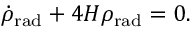<formula> <loc_0><loc_0><loc_500><loc_500>{ \dot { \rho } } _ { r a d } + 4 H \rho _ { r a d } = 0 .</formula> 